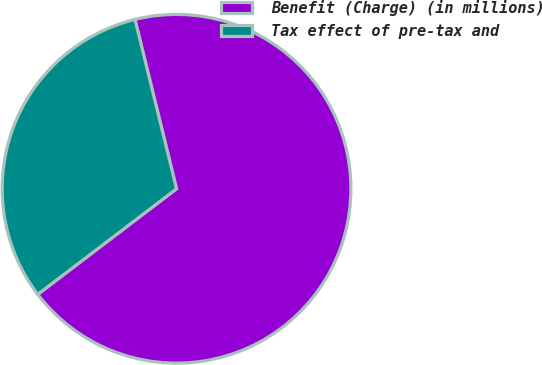<chart> <loc_0><loc_0><loc_500><loc_500><pie_chart><fcel>Benefit (Charge) (in millions)<fcel>Tax effect of pre-tax and<nl><fcel>68.48%<fcel>31.52%<nl></chart> 